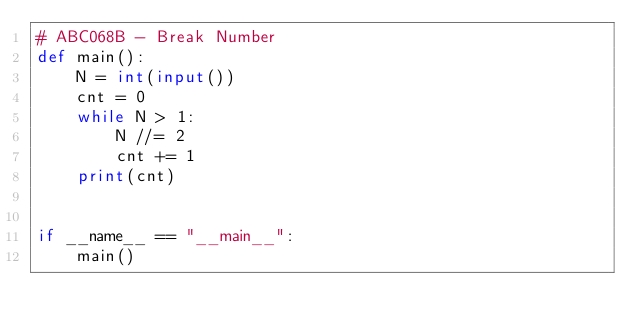<code> <loc_0><loc_0><loc_500><loc_500><_Python_># ABC068B - Break Number
def main():
    N = int(input())
    cnt = 0
    while N > 1:
        N //= 2
        cnt += 1
    print(cnt)


if __name__ == "__main__":
    main()</code> 